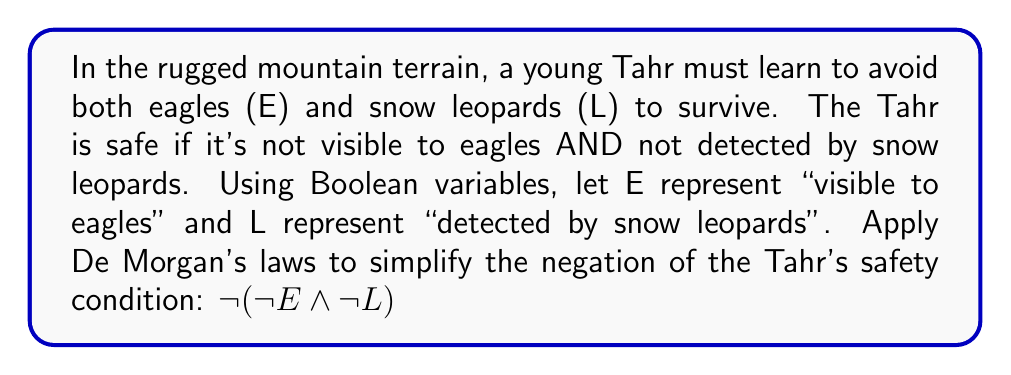Solve this math problem. Let's apply De Morgan's laws step-by-step to simplify the given expression:

1) Start with the original expression:
   $\neg(\neg E \land \neg L)$

2) De Morgan's first law states that the negation of a conjunction is the disjunction of the negations. In other words:
   $\neg(A \land B) = \neg A \lor \neg B$

3) Applying this law to our expression:
   $\neg(\neg E \land \neg L) = \neg(\neg E) \lor \neg(\neg L)$

4) The double negation of a variable is equivalent to the variable itself:
   $\neg(\neg X) = X$

5) Applying this to both terms:
   $\neg(\neg E) \lor \neg(\neg L) = E \lor L$

Therefore, the simplified expression is $E \lor L$.

This result means that the negation of the Tahr's safety condition (not being visible to eagles AND not being detected by snow leopards) is equivalent to being visible to eagles OR being detected by snow leopards.
Answer: $E \lor L$ 